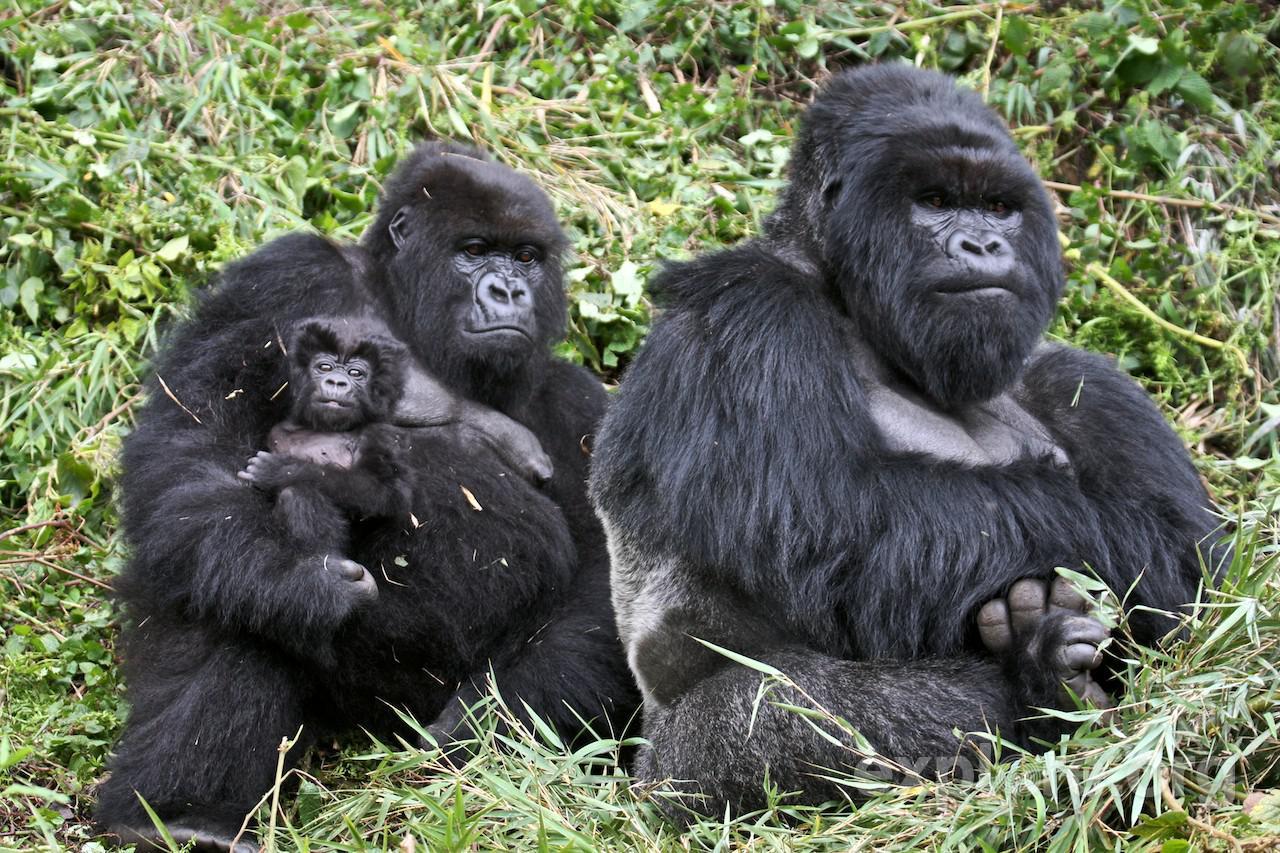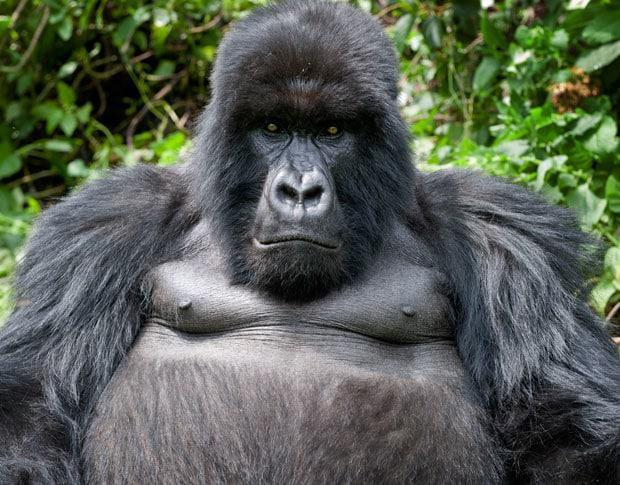The first image is the image on the left, the second image is the image on the right. For the images shown, is this caption "The right image contains no more than two gorillas." true? Answer yes or no. Yes. The first image is the image on the left, the second image is the image on the right. Evaluate the accuracy of this statement regarding the images: "An image shows exactly one gorilla, which is posed with its chest facing the camera.". Is it true? Answer yes or no. Yes. 